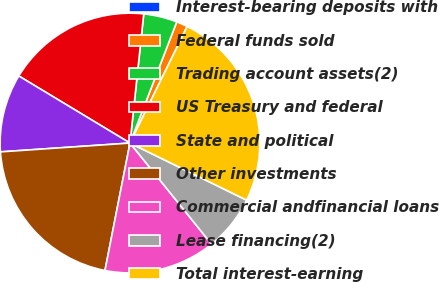Convert chart. <chart><loc_0><loc_0><loc_500><loc_500><pie_chart><fcel>Interest-bearing deposits with<fcel>Federal funds sold<fcel>Trading account assets(2)<fcel>US Treasury and federal<fcel>State and political<fcel>Other investments<fcel>Commercial andfinancial loans<fcel>Lease financing(2)<fcel>Total interest-earning<nl><fcel>0.01%<fcel>1.39%<fcel>4.17%<fcel>18.05%<fcel>9.72%<fcel>20.83%<fcel>13.89%<fcel>6.95%<fcel>24.99%<nl></chart> 